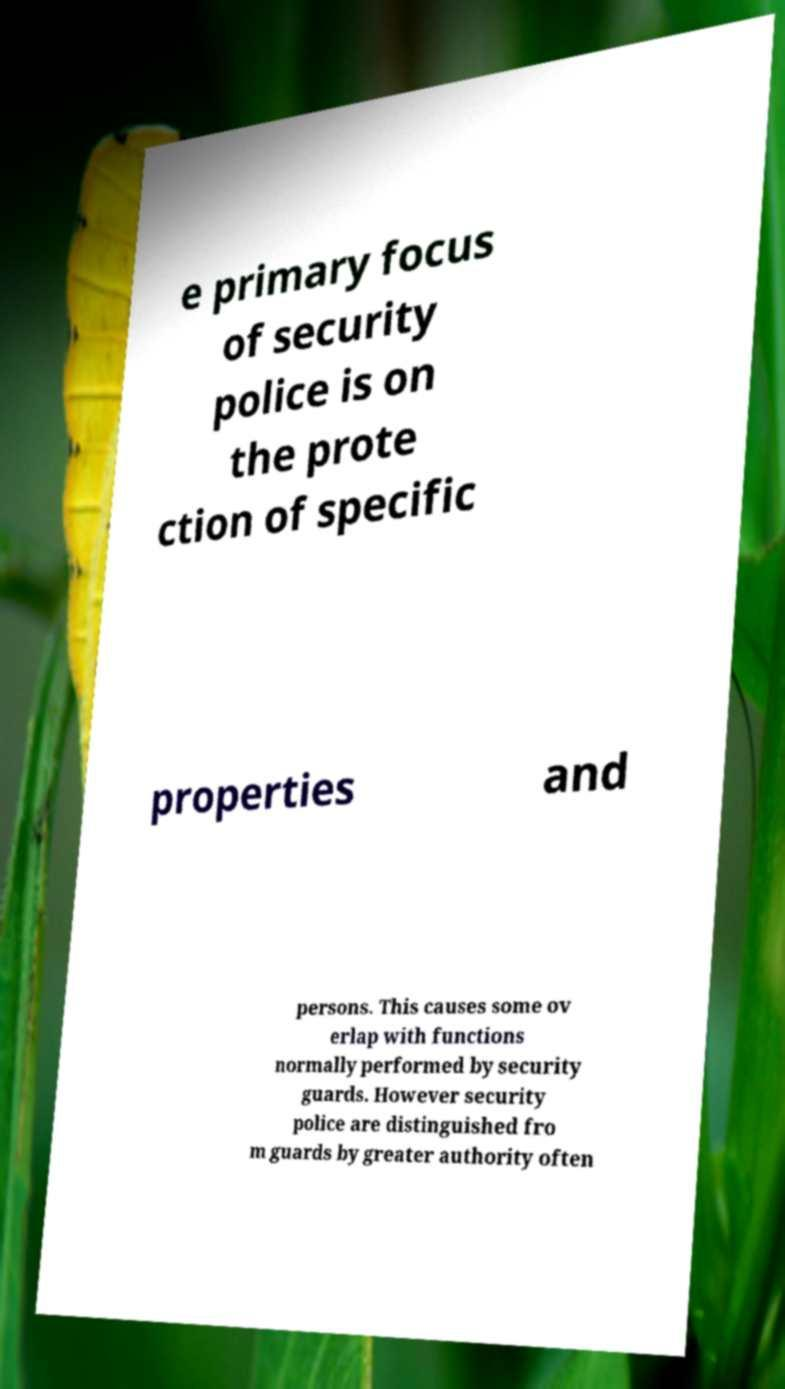Please identify and transcribe the text found in this image. e primary focus of security police is on the prote ction of specific properties and persons. This causes some ov erlap with functions normally performed by security guards. However security police are distinguished fro m guards by greater authority often 